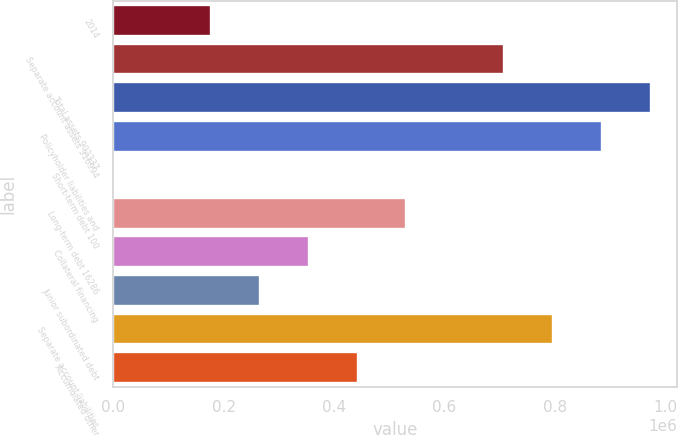Convert chart. <chart><loc_0><loc_0><loc_500><loc_500><bar_chart><fcel>2014<fcel>Separate account assets 316994<fcel>Total assets 902337<fcel>Policyholder liabilities and<fcel>Short-term debt 100<fcel>Long-term debt 16286<fcel>Collateral financing<fcel>Junior subordinated debt<fcel>Separate account liabilities<fcel>Accumulated other<nl><fcel>177199<fcel>708272<fcel>973808<fcel>885296<fcel>175<fcel>531248<fcel>354223<fcel>265711<fcel>796784<fcel>442736<nl></chart> 